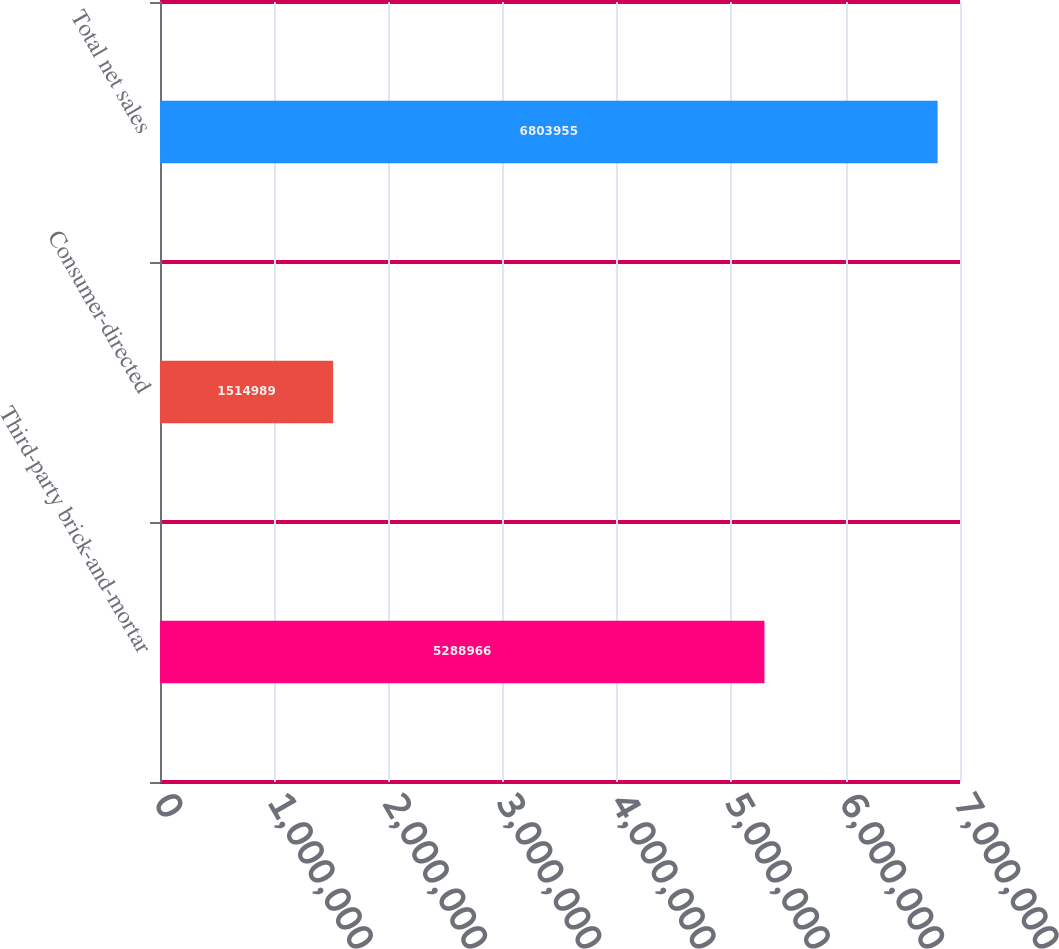Convert chart. <chart><loc_0><loc_0><loc_500><loc_500><bar_chart><fcel>Third-party brick-and-mortar<fcel>Consumer-directed<fcel>Total net sales<nl><fcel>5.28897e+06<fcel>1.51499e+06<fcel>6.80396e+06<nl></chart> 